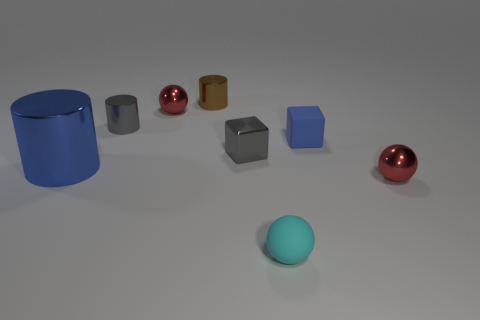Are there any large gray blocks that have the same material as the gray cylinder?
Offer a terse response. No. What material is the cube that is left of the small rubber ball?
Your response must be concise. Metal. What is the material of the small brown cylinder?
Your answer should be compact. Metal. Are the small blue block that is right of the metal cube and the gray cube made of the same material?
Give a very brief answer. No. Are there fewer brown shiny things that are left of the blue shiny object than shiny blocks?
Make the answer very short. Yes. What is the color of the rubber cube that is the same size as the gray cylinder?
Your answer should be compact. Blue. What number of other tiny things have the same shape as the tiny blue thing?
Provide a succinct answer. 1. There is a cylinder in front of the tiny gray block; what is its color?
Provide a short and direct response. Blue. How many rubber things are either big blue blocks or blocks?
Ensure brevity in your answer.  1. What shape is the thing that is the same color as the rubber cube?
Your answer should be very brief. Cylinder. 